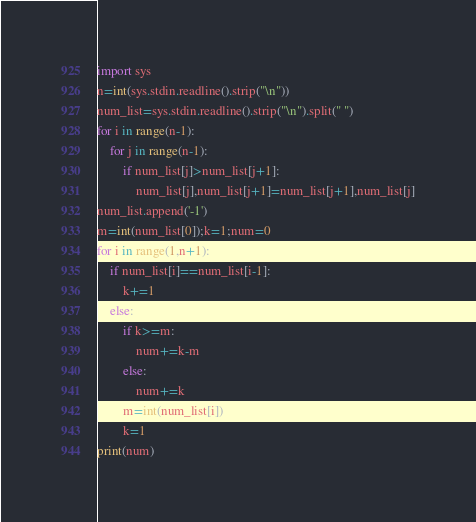Convert code to text. <code><loc_0><loc_0><loc_500><loc_500><_Python_>import sys
n=int(sys.stdin.readline().strip("\n"))
num_list=sys.stdin.readline().strip("\n").split(" ")
for i in range(n-1):
    for j in range(n-1):
        if num_list[j]>num_list[j+1]:
            num_list[j],num_list[j+1]=num_list[j+1],num_list[j]
num_list.append('-1')
m=int(num_list[0]);k=1;num=0
for i in range(1,n+1):
    if num_list[i]==num_list[i-1]:
        k+=1
    else:
        if k>=m:
            num+=k-m
        else:
            num+=k
        m=int(num_list[i])
        k=1
print(num)
</code> 